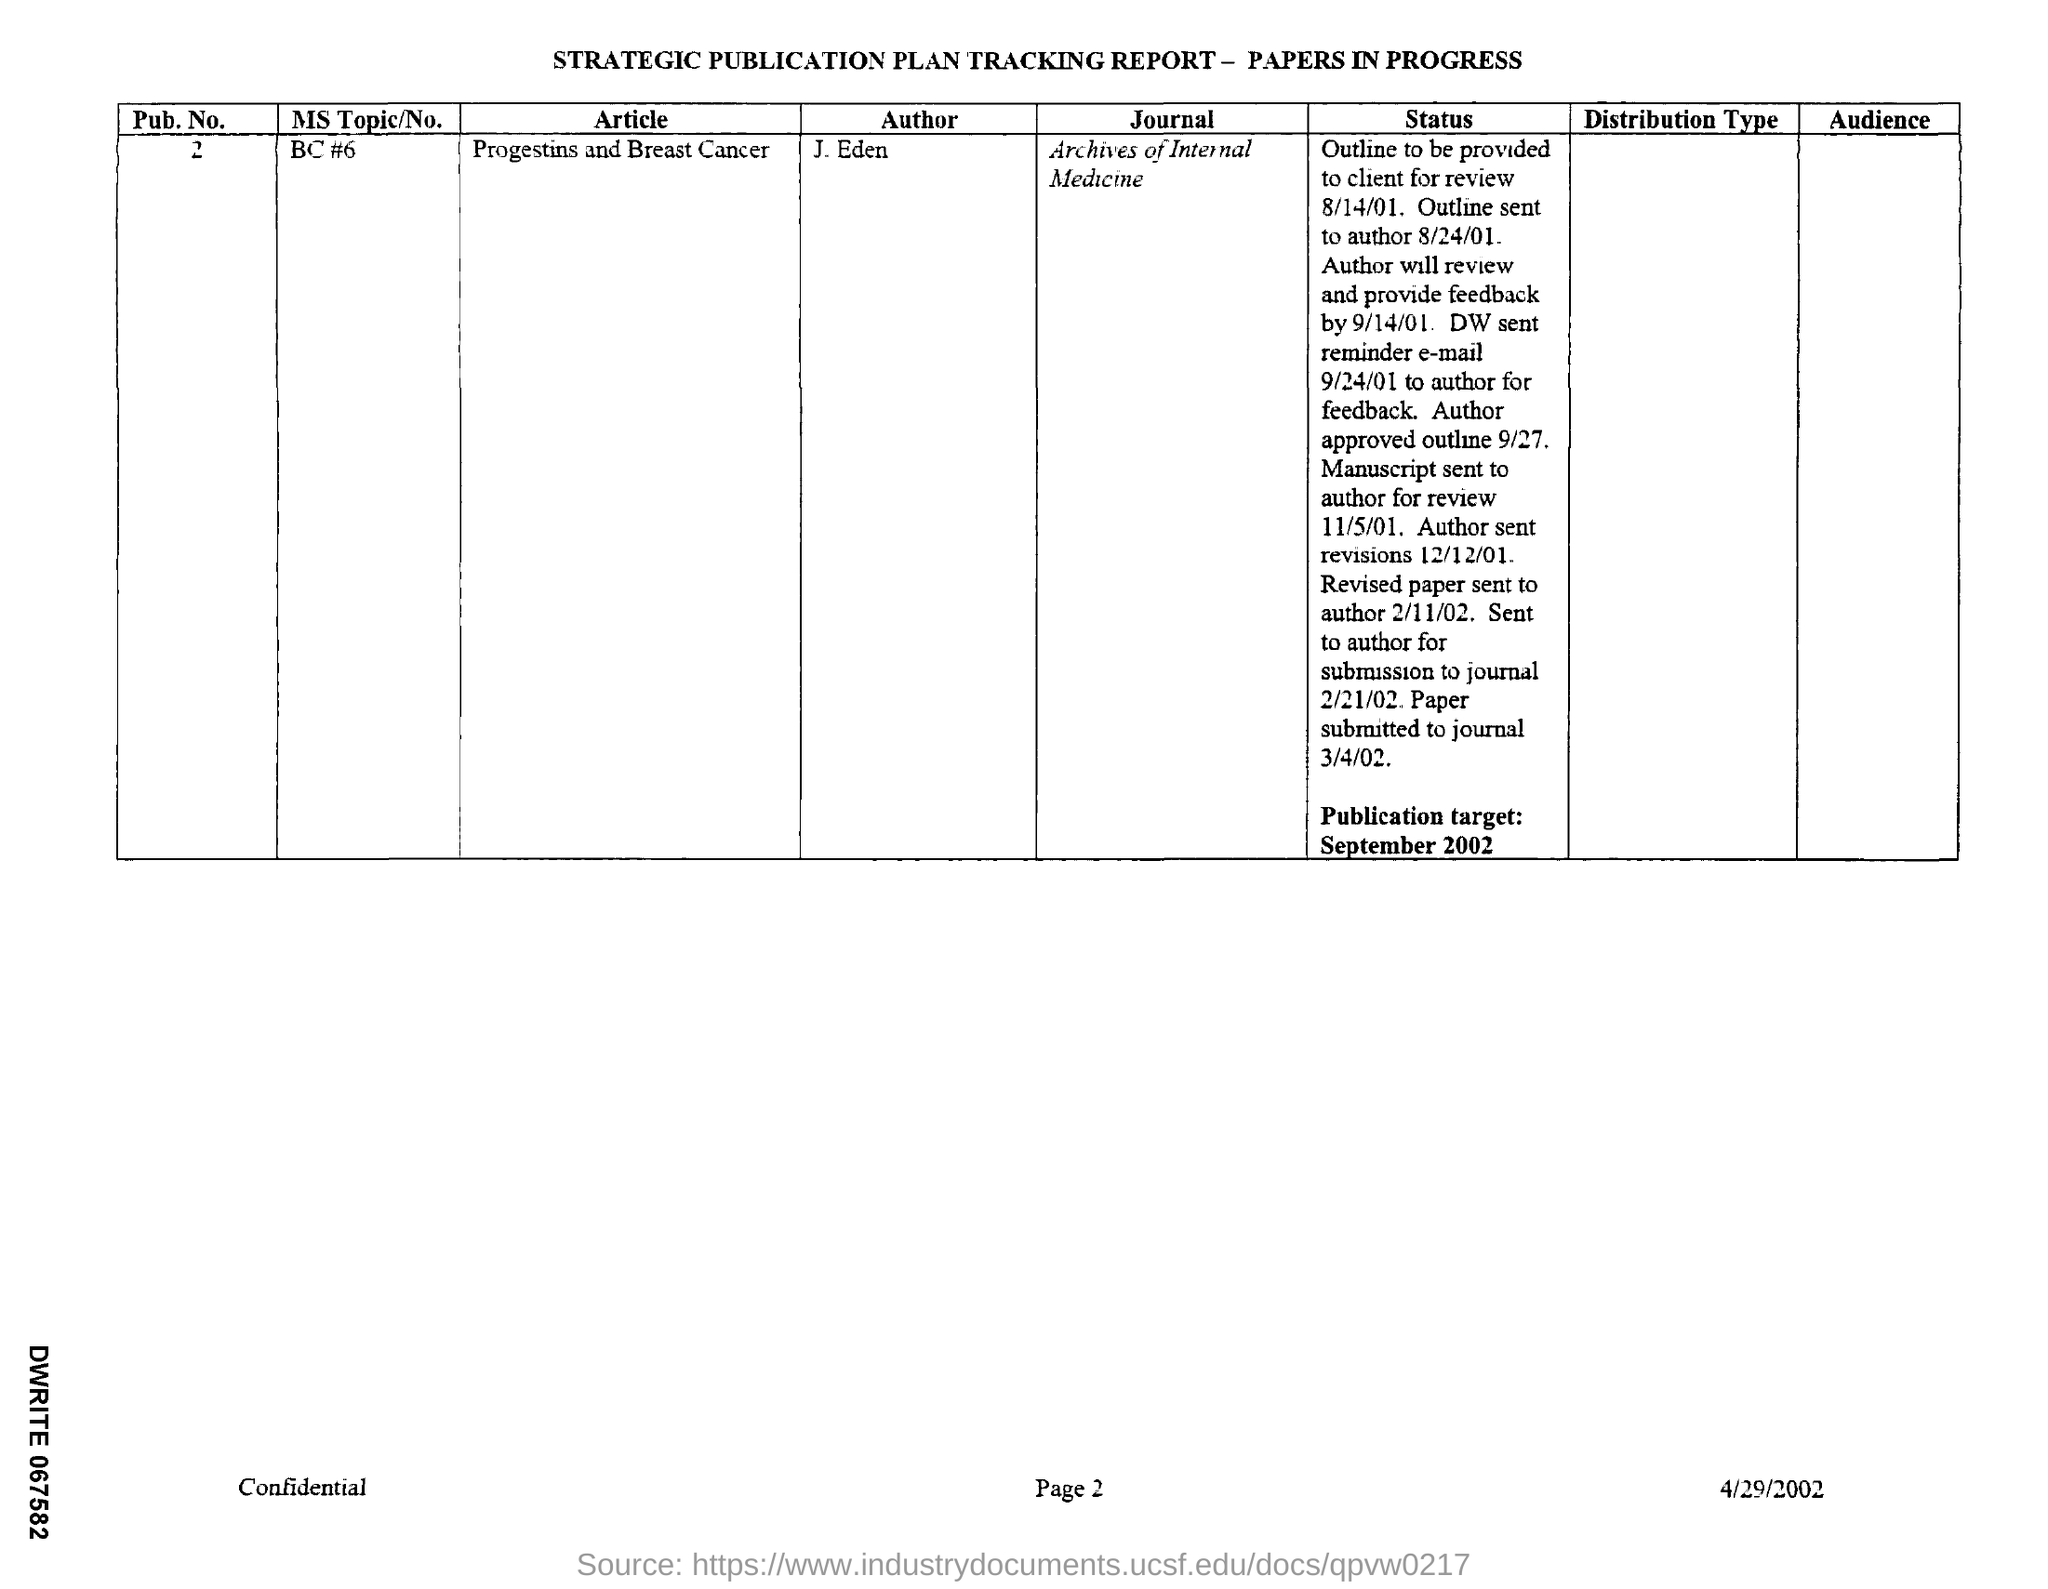Mention a couple of crucial points in this snapshot. This article is titled 'Progestins and Breast Cancer'. The Publication No. is 2. The paper was submitted to the journal on March 4, 2002. The paper will be published in the Archives of Internal Medicine. The publication is scheduled for September 2002. 